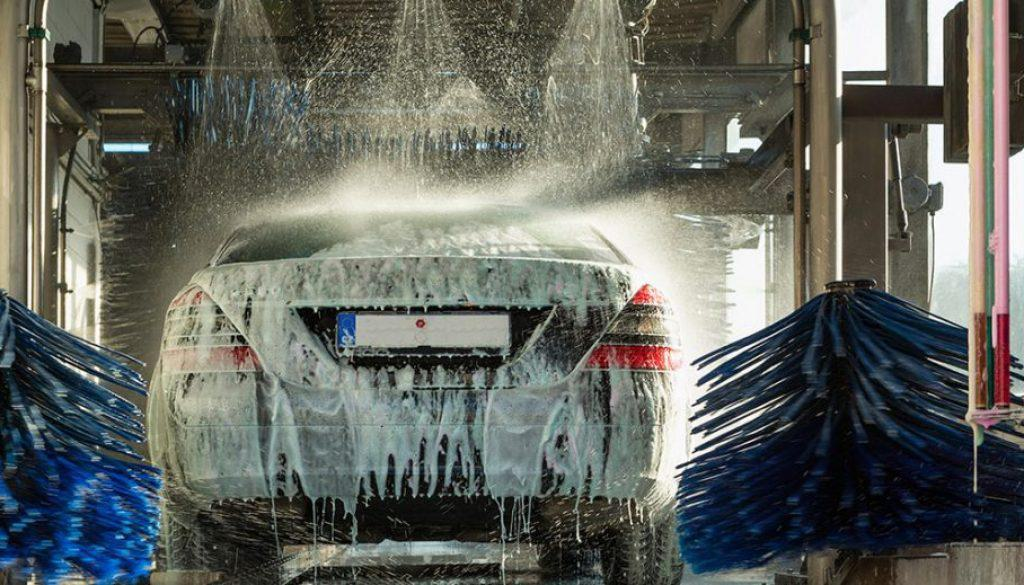Is there a car in the image? Yes, there is a car undergoing a wash in an automated car wash facility, complete with soap suds and washing brushes in action. 